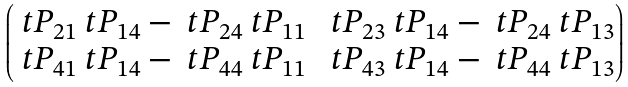<formula> <loc_0><loc_0><loc_500><loc_500>\begin{pmatrix} \ t P _ { 2 1 } \ t P _ { 1 4 } - \ t P _ { 2 4 } \ t P _ { 1 1 } & \ t P _ { 2 3 } \ t P _ { 1 4 } - \ t P _ { 2 4 } \ t P _ { 1 3 } \\ \ t P _ { 4 1 } \ t P _ { 1 4 } - \ t P _ { 4 4 } \ t P _ { 1 1 } & \ t P _ { 4 3 } \ t P _ { 1 4 } - \ t P _ { 4 4 } \ t P _ { 1 3 } \end{pmatrix}</formula> 